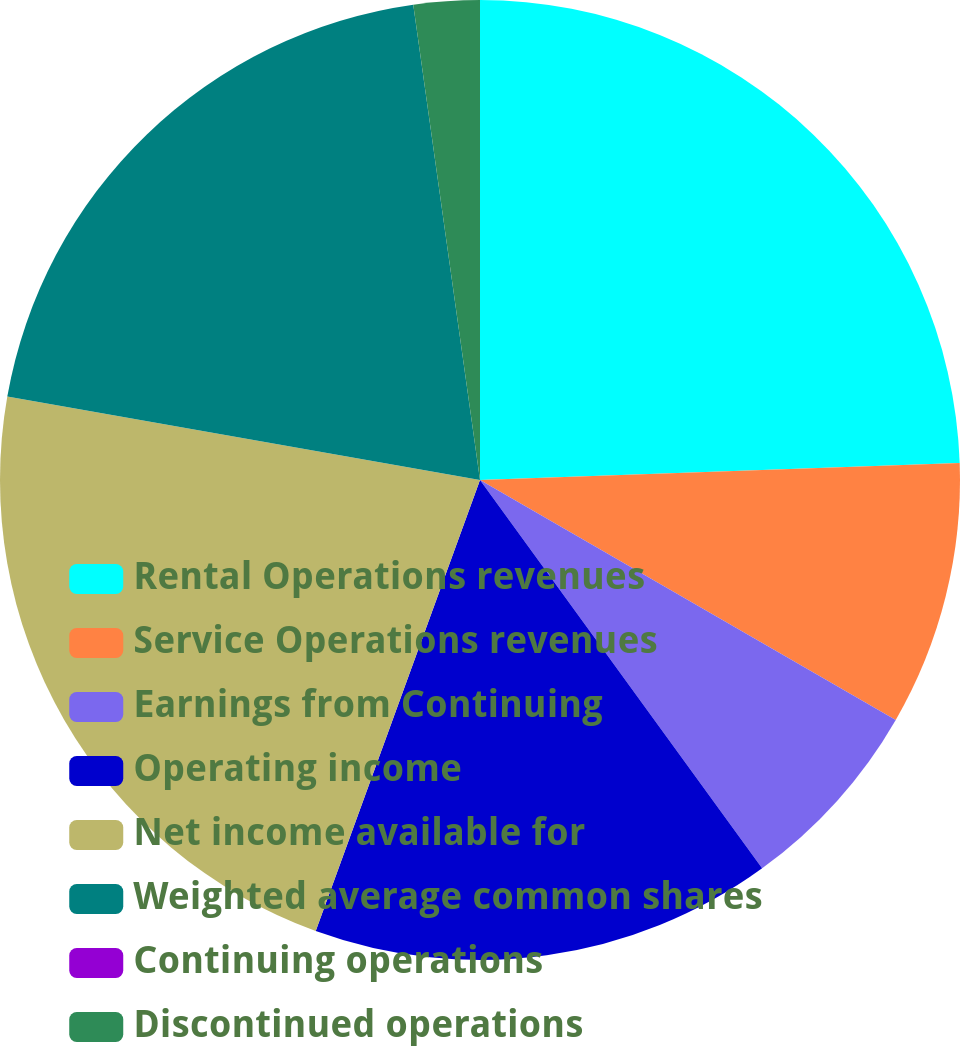Convert chart. <chart><loc_0><loc_0><loc_500><loc_500><pie_chart><fcel>Rental Operations revenues<fcel>Service Operations revenues<fcel>Earnings from Continuing<fcel>Operating income<fcel>Net income available for<fcel>Weighted average common shares<fcel>Continuing operations<fcel>Discontinued operations<nl><fcel>24.44%<fcel>8.89%<fcel>6.67%<fcel>15.56%<fcel>22.22%<fcel>20.0%<fcel>0.0%<fcel>2.22%<nl></chart> 